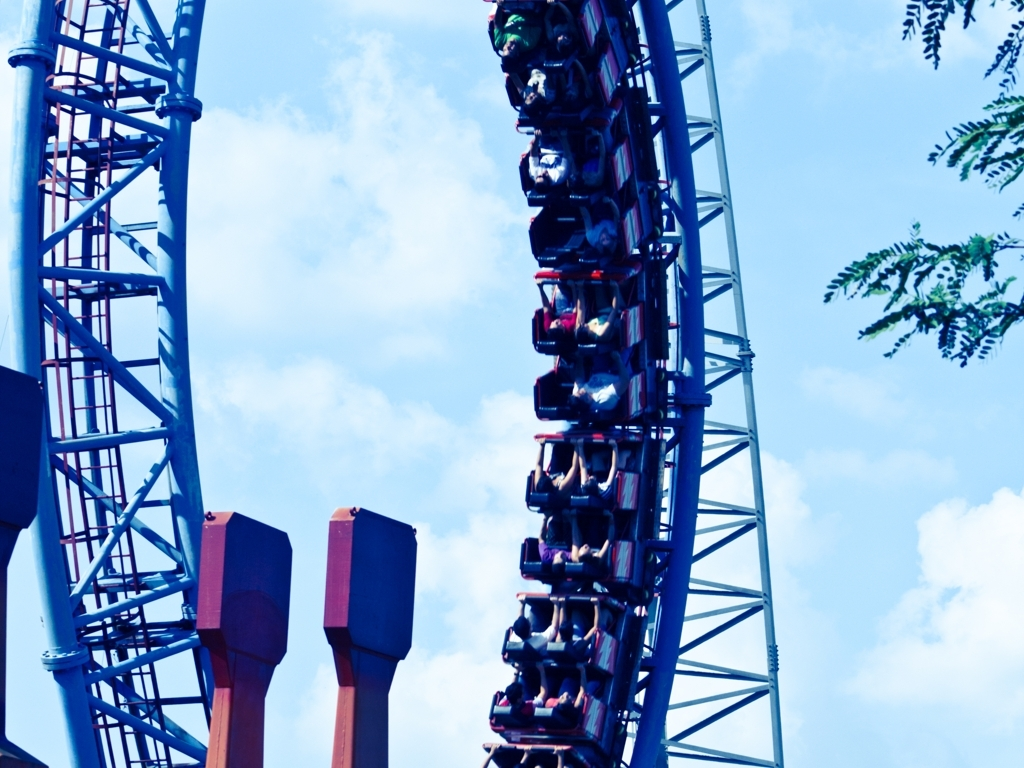What is the lighting like in this photo? The photo shows bright, natural daylight with soft shadows indicating it's taken on a clear day. The light appears to be coming from above and slightly in front of the roller coaster, which suggests it's midday or early afternoon. 